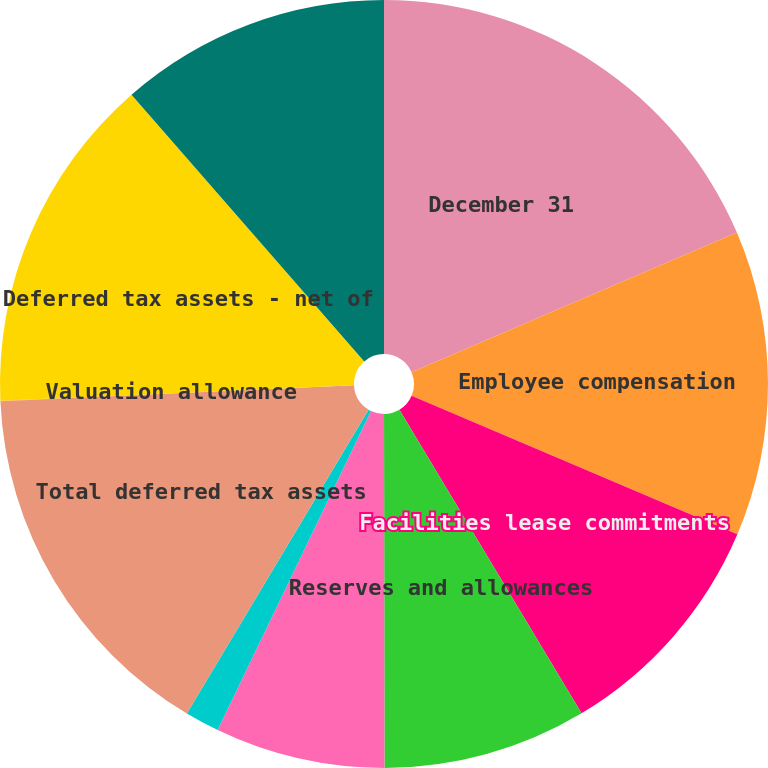<chart> <loc_0><loc_0><loc_500><loc_500><pie_chart><fcel>December 31<fcel>Employee compensation<fcel>Facilities lease commitments<fcel>Reserves and allowances<fcel>State and local taxes<fcel>Net operating loss<fcel>Total deferred tax assets<fcel>Valuation allowance<fcel>Deferred tax assets - net of<fcel>Depreciation and amortization<nl><fcel>18.55%<fcel>12.85%<fcel>10.0%<fcel>8.58%<fcel>7.15%<fcel>1.45%<fcel>15.7%<fcel>0.03%<fcel>14.27%<fcel>11.42%<nl></chart> 